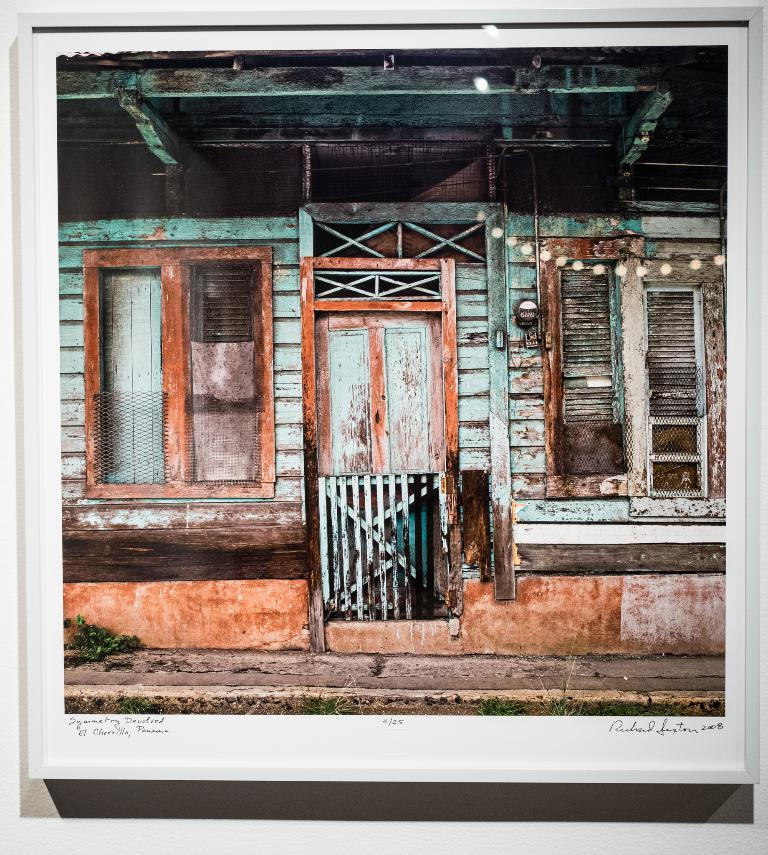What type of structure is visible in the image? There is a house in the image. How many windows are on the house? The house has two windows. What is the primary entrance to the house? The house has a door. What type of fang can be seen in the image? There is no fang present in the image; it features a house with windows and a door. How does the house mark its territory in the image? The image does not depict the house marking its territory, as houses do not have the ability to mark territory like animals do. 